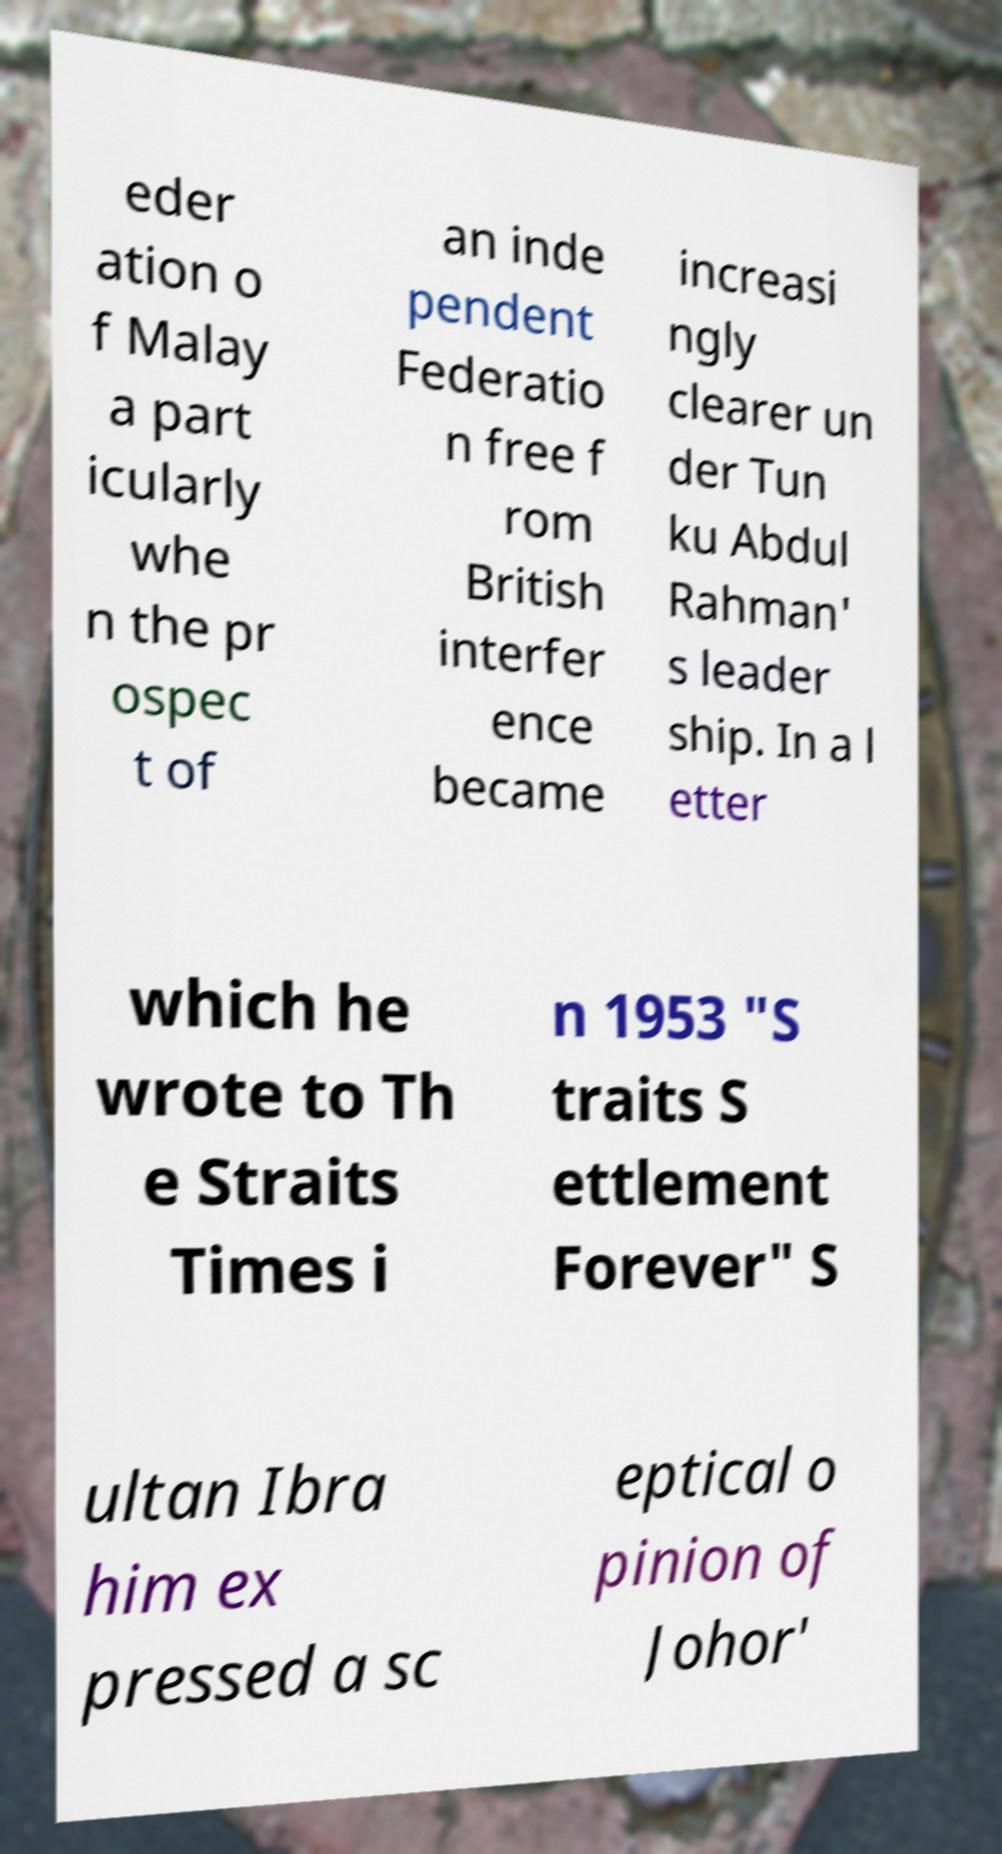Could you assist in decoding the text presented in this image and type it out clearly? eder ation o f Malay a part icularly whe n the pr ospec t of an inde pendent Federatio n free f rom British interfer ence became increasi ngly clearer un der Tun ku Abdul Rahman' s leader ship. In a l etter which he wrote to Th e Straits Times i n 1953 "S traits S ettlement Forever" S ultan Ibra him ex pressed a sc eptical o pinion of Johor' 